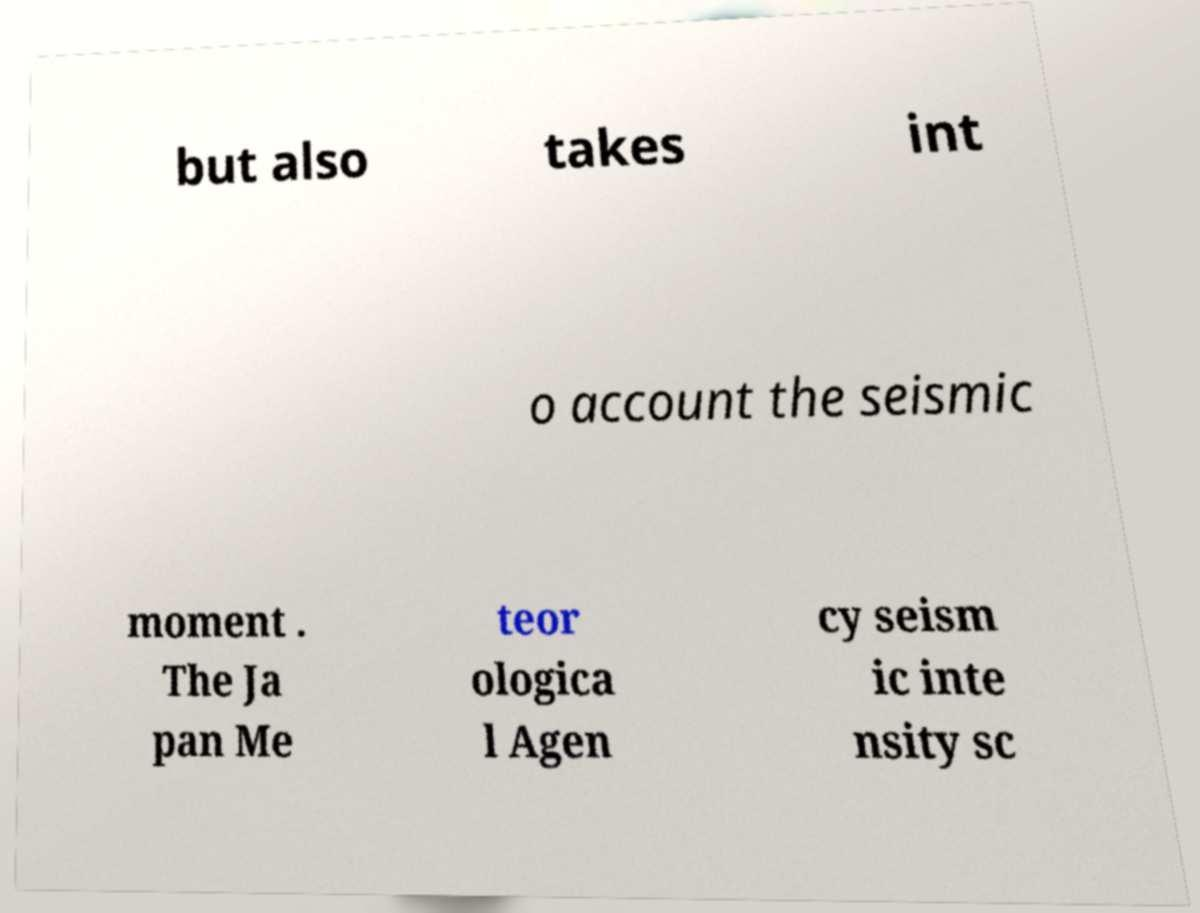There's text embedded in this image that I need extracted. Can you transcribe it verbatim? but also takes int o account the seismic moment . The Ja pan Me teor ologica l Agen cy seism ic inte nsity sc 